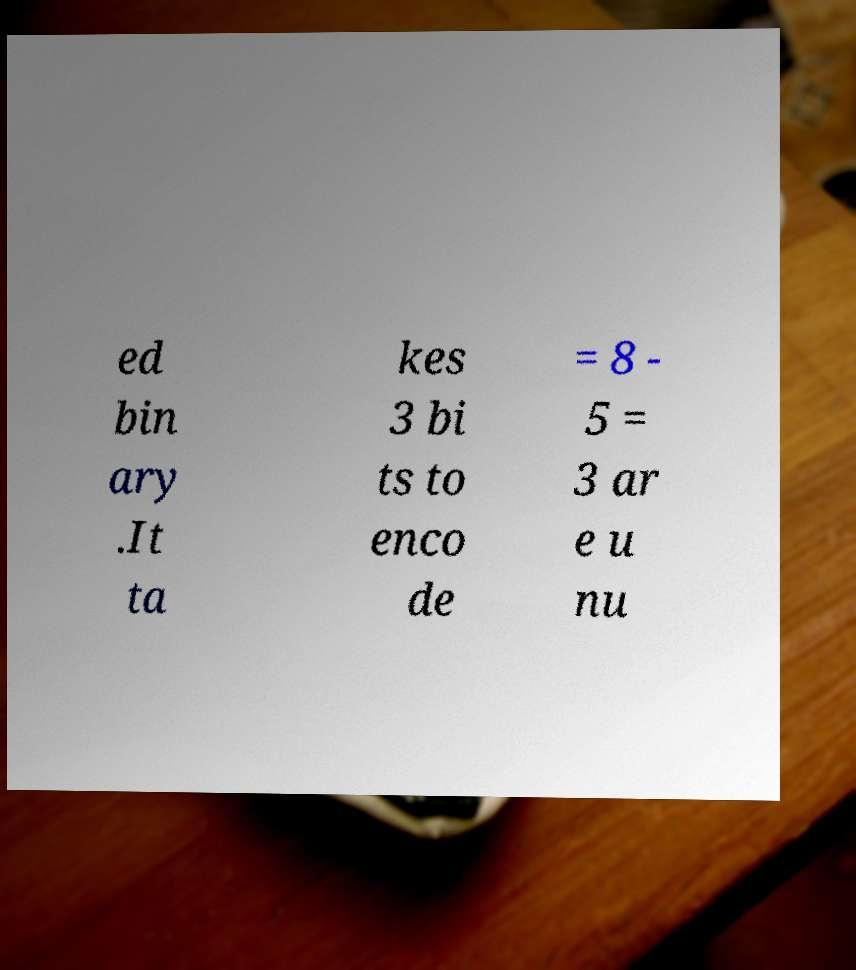Could you assist in decoding the text presented in this image and type it out clearly? ed bin ary .It ta kes 3 bi ts to enco de = 8 - 5 = 3 ar e u nu 